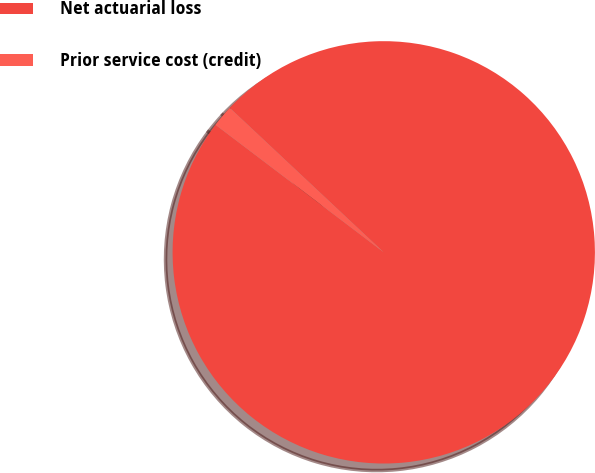Convert chart to OTSL. <chart><loc_0><loc_0><loc_500><loc_500><pie_chart><fcel>Net actuarial loss<fcel>Prior service cost (credit)<nl><fcel>98.33%<fcel>1.67%<nl></chart> 